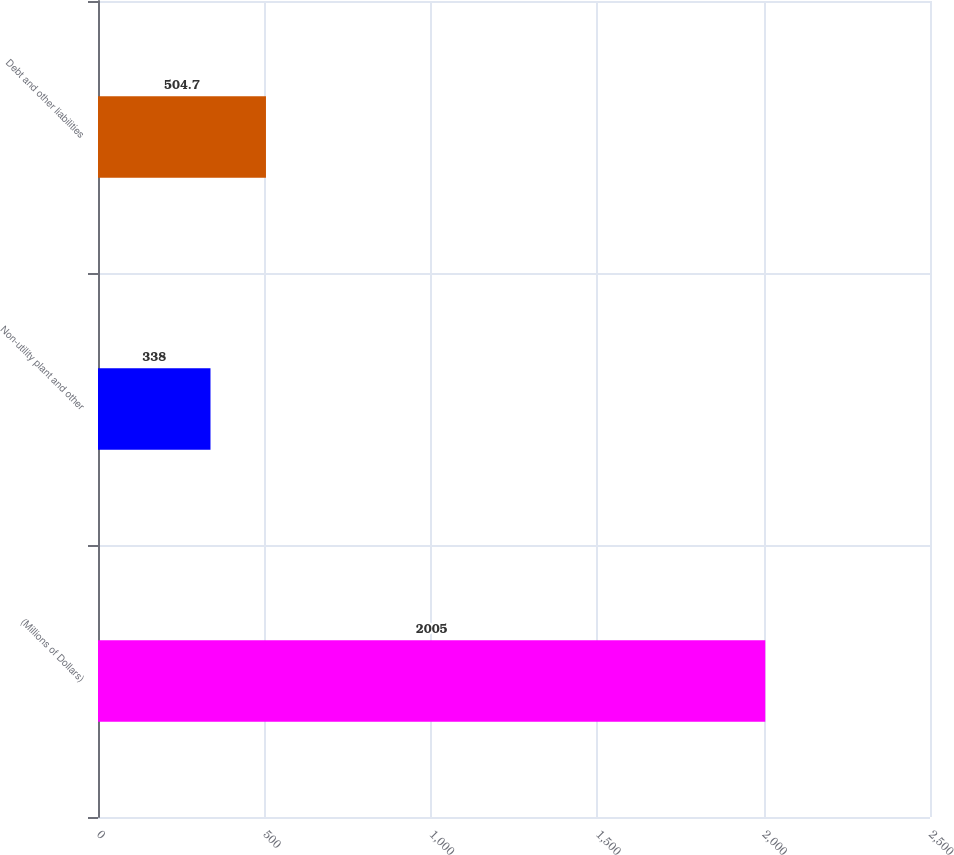Convert chart. <chart><loc_0><loc_0><loc_500><loc_500><bar_chart><fcel>(Millions of Dollars)<fcel>Non-utility plant and other<fcel>Debt and other liabilities<nl><fcel>2005<fcel>338<fcel>504.7<nl></chart> 